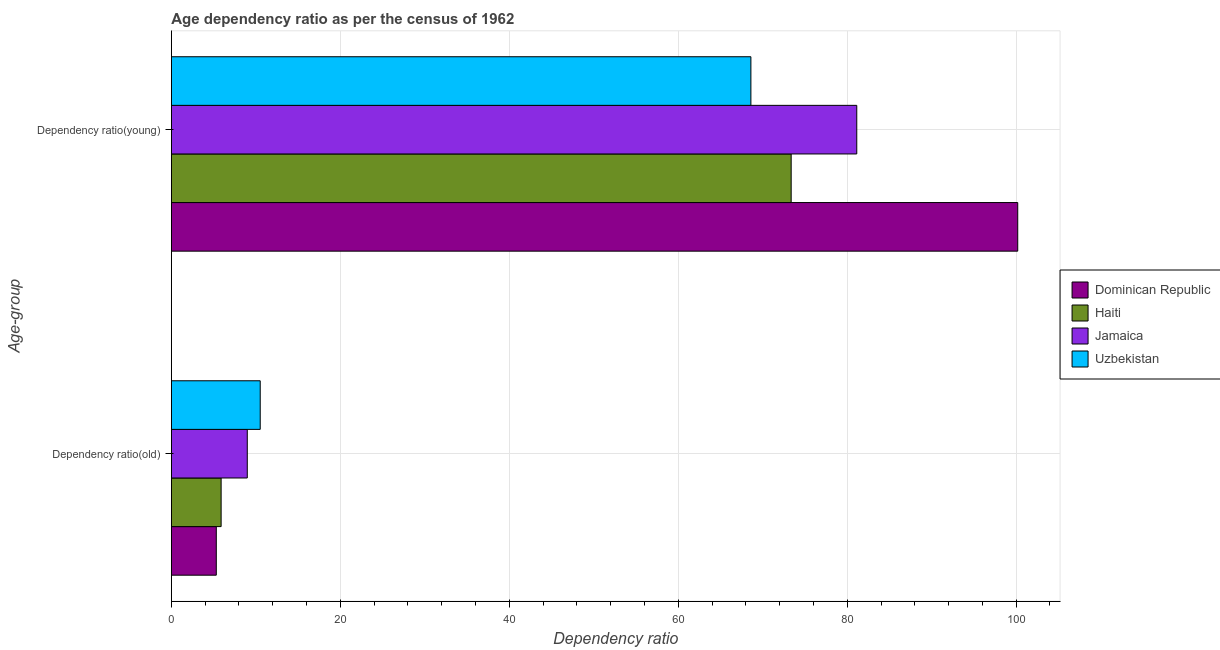Are the number of bars per tick equal to the number of legend labels?
Offer a terse response. Yes. How many bars are there on the 1st tick from the bottom?
Provide a succinct answer. 4. What is the label of the 1st group of bars from the top?
Provide a succinct answer. Dependency ratio(young). What is the age dependency ratio(young) in Uzbekistan?
Give a very brief answer. 68.6. Across all countries, what is the maximum age dependency ratio(young)?
Provide a succinct answer. 100.19. Across all countries, what is the minimum age dependency ratio(young)?
Your response must be concise. 68.6. In which country was the age dependency ratio(young) maximum?
Your answer should be very brief. Dominican Republic. In which country was the age dependency ratio(old) minimum?
Ensure brevity in your answer.  Dominican Republic. What is the total age dependency ratio(young) in the graph?
Your answer should be very brief. 323.28. What is the difference between the age dependency ratio(old) in Jamaica and that in Dominican Republic?
Make the answer very short. 3.67. What is the difference between the age dependency ratio(young) in Jamaica and the age dependency ratio(old) in Uzbekistan?
Provide a short and direct response. 70.61. What is the average age dependency ratio(young) per country?
Make the answer very short. 80.82. What is the difference between the age dependency ratio(old) and age dependency ratio(young) in Jamaica?
Your answer should be compact. -72.15. What is the ratio of the age dependency ratio(old) in Dominican Republic to that in Jamaica?
Your response must be concise. 0.59. What does the 2nd bar from the top in Dependency ratio(young) represents?
Your answer should be very brief. Jamaica. What does the 3rd bar from the bottom in Dependency ratio(old) represents?
Keep it short and to the point. Jamaica. Are the values on the major ticks of X-axis written in scientific E-notation?
Offer a very short reply. No. Does the graph contain grids?
Your answer should be compact. Yes. Where does the legend appear in the graph?
Make the answer very short. Center right. What is the title of the graph?
Your answer should be compact. Age dependency ratio as per the census of 1962. Does "Mali" appear as one of the legend labels in the graph?
Give a very brief answer. No. What is the label or title of the X-axis?
Ensure brevity in your answer.  Dependency ratio. What is the label or title of the Y-axis?
Offer a terse response. Age-group. What is the Dependency ratio in Dominican Republic in Dependency ratio(old)?
Keep it short and to the point. 5.32. What is the Dependency ratio of Haiti in Dependency ratio(old)?
Your answer should be very brief. 5.89. What is the Dependency ratio of Jamaica in Dependency ratio(old)?
Make the answer very short. 8.98. What is the Dependency ratio in Uzbekistan in Dependency ratio(old)?
Offer a terse response. 10.52. What is the Dependency ratio of Dominican Republic in Dependency ratio(young)?
Your response must be concise. 100.19. What is the Dependency ratio in Haiti in Dependency ratio(young)?
Your response must be concise. 73.37. What is the Dependency ratio in Jamaica in Dependency ratio(young)?
Ensure brevity in your answer.  81.13. What is the Dependency ratio in Uzbekistan in Dependency ratio(young)?
Provide a short and direct response. 68.6. Across all Age-group, what is the maximum Dependency ratio of Dominican Republic?
Your answer should be very brief. 100.19. Across all Age-group, what is the maximum Dependency ratio in Haiti?
Ensure brevity in your answer.  73.37. Across all Age-group, what is the maximum Dependency ratio in Jamaica?
Your answer should be very brief. 81.13. Across all Age-group, what is the maximum Dependency ratio of Uzbekistan?
Your response must be concise. 68.6. Across all Age-group, what is the minimum Dependency ratio in Dominican Republic?
Make the answer very short. 5.32. Across all Age-group, what is the minimum Dependency ratio in Haiti?
Your response must be concise. 5.89. Across all Age-group, what is the minimum Dependency ratio of Jamaica?
Your answer should be compact. 8.98. Across all Age-group, what is the minimum Dependency ratio in Uzbekistan?
Offer a very short reply. 10.52. What is the total Dependency ratio in Dominican Republic in the graph?
Provide a short and direct response. 105.5. What is the total Dependency ratio of Haiti in the graph?
Provide a short and direct response. 79.25. What is the total Dependency ratio of Jamaica in the graph?
Make the answer very short. 90.12. What is the total Dependency ratio in Uzbekistan in the graph?
Offer a terse response. 79.11. What is the difference between the Dependency ratio of Dominican Republic in Dependency ratio(old) and that in Dependency ratio(young)?
Your answer should be very brief. -94.87. What is the difference between the Dependency ratio in Haiti in Dependency ratio(old) and that in Dependency ratio(young)?
Keep it short and to the point. -67.48. What is the difference between the Dependency ratio in Jamaica in Dependency ratio(old) and that in Dependency ratio(young)?
Provide a succinct answer. -72.15. What is the difference between the Dependency ratio of Uzbekistan in Dependency ratio(old) and that in Dependency ratio(young)?
Give a very brief answer. -58.08. What is the difference between the Dependency ratio in Dominican Republic in Dependency ratio(old) and the Dependency ratio in Haiti in Dependency ratio(young)?
Offer a terse response. -68.05. What is the difference between the Dependency ratio of Dominican Republic in Dependency ratio(old) and the Dependency ratio of Jamaica in Dependency ratio(young)?
Provide a short and direct response. -75.81. What is the difference between the Dependency ratio in Dominican Republic in Dependency ratio(old) and the Dependency ratio in Uzbekistan in Dependency ratio(young)?
Make the answer very short. -63.28. What is the difference between the Dependency ratio in Haiti in Dependency ratio(old) and the Dependency ratio in Jamaica in Dependency ratio(young)?
Provide a short and direct response. -75.24. What is the difference between the Dependency ratio in Haiti in Dependency ratio(old) and the Dependency ratio in Uzbekistan in Dependency ratio(young)?
Give a very brief answer. -62.71. What is the difference between the Dependency ratio of Jamaica in Dependency ratio(old) and the Dependency ratio of Uzbekistan in Dependency ratio(young)?
Give a very brief answer. -59.61. What is the average Dependency ratio of Dominican Republic per Age-group?
Keep it short and to the point. 52.75. What is the average Dependency ratio in Haiti per Age-group?
Provide a succinct answer. 39.63. What is the average Dependency ratio in Jamaica per Age-group?
Keep it short and to the point. 45.06. What is the average Dependency ratio in Uzbekistan per Age-group?
Your response must be concise. 39.56. What is the difference between the Dependency ratio of Dominican Republic and Dependency ratio of Haiti in Dependency ratio(old)?
Offer a terse response. -0.57. What is the difference between the Dependency ratio of Dominican Republic and Dependency ratio of Jamaica in Dependency ratio(old)?
Ensure brevity in your answer.  -3.67. What is the difference between the Dependency ratio of Dominican Republic and Dependency ratio of Uzbekistan in Dependency ratio(old)?
Give a very brief answer. -5.2. What is the difference between the Dependency ratio of Haiti and Dependency ratio of Jamaica in Dependency ratio(old)?
Your response must be concise. -3.1. What is the difference between the Dependency ratio of Haiti and Dependency ratio of Uzbekistan in Dependency ratio(old)?
Your answer should be very brief. -4.63. What is the difference between the Dependency ratio of Jamaica and Dependency ratio of Uzbekistan in Dependency ratio(old)?
Offer a very short reply. -1.53. What is the difference between the Dependency ratio of Dominican Republic and Dependency ratio of Haiti in Dependency ratio(young)?
Provide a succinct answer. 26.82. What is the difference between the Dependency ratio in Dominican Republic and Dependency ratio in Jamaica in Dependency ratio(young)?
Your answer should be very brief. 19.05. What is the difference between the Dependency ratio of Dominican Republic and Dependency ratio of Uzbekistan in Dependency ratio(young)?
Offer a very short reply. 31.59. What is the difference between the Dependency ratio of Haiti and Dependency ratio of Jamaica in Dependency ratio(young)?
Offer a terse response. -7.77. What is the difference between the Dependency ratio of Haiti and Dependency ratio of Uzbekistan in Dependency ratio(young)?
Ensure brevity in your answer.  4.77. What is the difference between the Dependency ratio of Jamaica and Dependency ratio of Uzbekistan in Dependency ratio(young)?
Keep it short and to the point. 12.53. What is the ratio of the Dependency ratio of Dominican Republic in Dependency ratio(old) to that in Dependency ratio(young)?
Provide a succinct answer. 0.05. What is the ratio of the Dependency ratio in Haiti in Dependency ratio(old) to that in Dependency ratio(young)?
Offer a terse response. 0.08. What is the ratio of the Dependency ratio of Jamaica in Dependency ratio(old) to that in Dependency ratio(young)?
Provide a succinct answer. 0.11. What is the ratio of the Dependency ratio of Uzbekistan in Dependency ratio(old) to that in Dependency ratio(young)?
Ensure brevity in your answer.  0.15. What is the difference between the highest and the second highest Dependency ratio in Dominican Republic?
Give a very brief answer. 94.87. What is the difference between the highest and the second highest Dependency ratio in Haiti?
Keep it short and to the point. 67.48. What is the difference between the highest and the second highest Dependency ratio in Jamaica?
Your answer should be very brief. 72.15. What is the difference between the highest and the second highest Dependency ratio in Uzbekistan?
Provide a short and direct response. 58.08. What is the difference between the highest and the lowest Dependency ratio of Dominican Republic?
Provide a succinct answer. 94.87. What is the difference between the highest and the lowest Dependency ratio of Haiti?
Offer a very short reply. 67.48. What is the difference between the highest and the lowest Dependency ratio in Jamaica?
Offer a terse response. 72.15. What is the difference between the highest and the lowest Dependency ratio of Uzbekistan?
Ensure brevity in your answer.  58.08. 